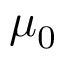<formula> <loc_0><loc_0><loc_500><loc_500>\mu _ { 0 }</formula> 